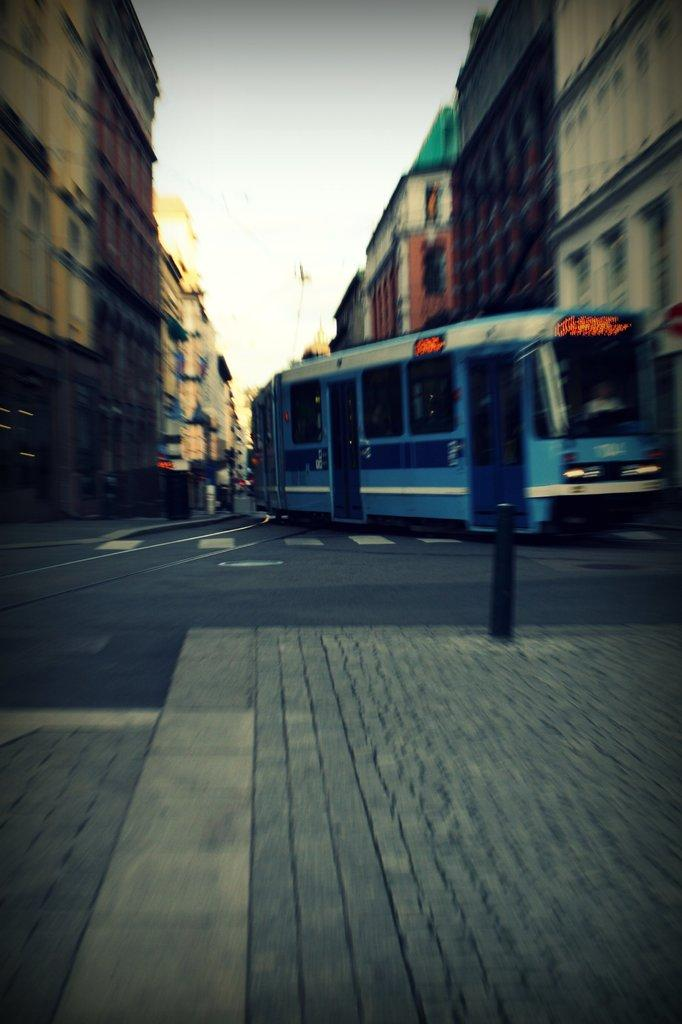What is the main subject in the image? The main subject in the image is a train. Where is the train located in the image? The train is in the middle of the image. What else can be seen in the image besides the train? There is a road and buildings in the background of the image. What is visible in the background of the image? The sky is visible in the background of the image. What type of dress is the train wearing in the image? Trains do not wear dresses; they are vehicles and do not have clothing. 